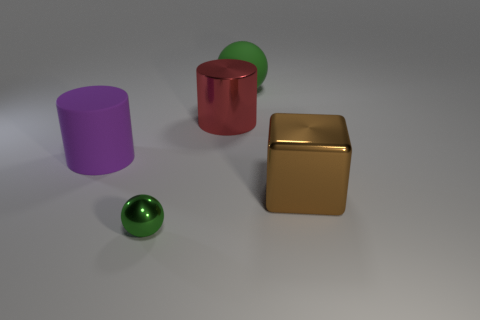The large red thing that is made of the same material as the small green thing is what shape?
Give a very brief answer. Cylinder. Is the large purple rubber thing the same shape as the big red shiny object?
Offer a very short reply. Yes. What is the material of the other object that is the same shape as the large purple thing?
Ensure brevity in your answer.  Metal. There is a big green rubber thing; is it the same shape as the green thing in front of the brown cube?
Your answer should be very brief. Yes. There is a object that is the same color as the small ball; what is its shape?
Your answer should be very brief. Sphere. How many balls are both behind the big red thing and in front of the green matte ball?
Offer a very short reply. 0. Is there anything else that has the same shape as the big green matte thing?
Give a very brief answer. Yes. What number of other objects are there of the same size as the purple object?
Provide a succinct answer. 3. Do the object that is to the right of the big green thing and the rubber object in front of the big green thing have the same size?
Offer a terse response. Yes. What number of objects are matte cylinders or green balls that are behind the matte cylinder?
Provide a succinct answer. 2. 